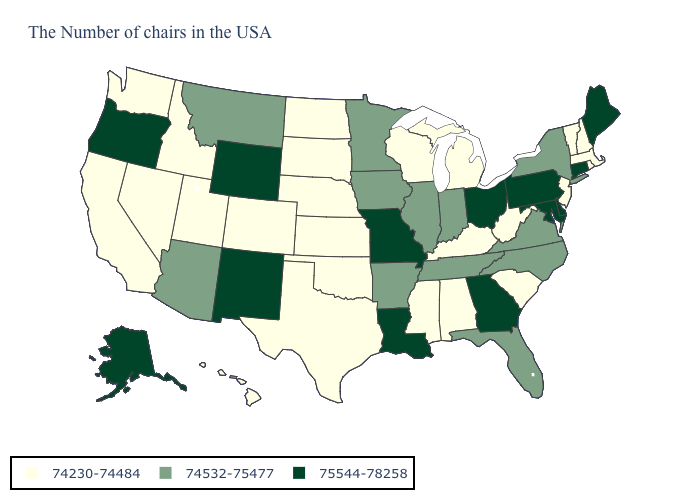Does Indiana have the same value as Minnesota?
Short answer required. Yes. How many symbols are there in the legend?
Write a very short answer. 3. What is the value of Arkansas?
Quick response, please. 74532-75477. What is the value of Kentucky?
Give a very brief answer. 74230-74484. Which states hav the highest value in the Northeast?
Concise answer only. Maine, Connecticut, Pennsylvania. Which states have the lowest value in the MidWest?
Give a very brief answer. Michigan, Wisconsin, Kansas, Nebraska, South Dakota, North Dakota. What is the highest value in states that border New Hampshire?
Keep it brief. 75544-78258. Name the states that have a value in the range 74230-74484?
Keep it brief. Massachusetts, Rhode Island, New Hampshire, Vermont, New Jersey, South Carolina, West Virginia, Michigan, Kentucky, Alabama, Wisconsin, Mississippi, Kansas, Nebraska, Oklahoma, Texas, South Dakota, North Dakota, Colorado, Utah, Idaho, Nevada, California, Washington, Hawaii. How many symbols are there in the legend?
Be succinct. 3. Which states have the highest value in the USA?
Answer briefly. Maine, Connecticut, Delaware, Maryland, Pennsylvania, Ohio, Georgia, Louisiana, Missouri, Wyoming, New Mexico, Oregon, Alaska. Does Delaware have the lowest value in the South?
Quick response, please. No. Does New York have the lowest value in the Northeast?
Write a very short answer. No. What is the highest value in states that border Texas?
Keep it brief. 75544-78258. Which states have the highest value in the USA?
Write a very short answer. Maine, Connecticut, Delaware, Maryland, Pennsylvania, Ohio, Georgia, Louisiana, Missouri, Wyoming, New Mexico, Oregon, Alaska. Does Utah have the highest value in the USA?
Keep it brief. No. 